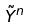Convert formula to latex. <formula><loc_0><loc_0><loc_500><loc_500>\tilde { Y } ^ { n }</formula> 